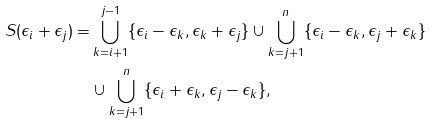Convert formula to latex. <formula><loc_0><loc_0><loc_500><loc_500>S ( \epsilon _ { i } + \epsilon _ { j } ) = & \bigcup _ { k = i + 1 } ^ { j - 1 } \{ \epsilon _ { i } - \epsilon _ { k } , \epsilon _ { k } + \epsilon _ { j } \} \cup \bigcup _ { k = j + 1 } ^ { n } \{ \epsilon _ { i } - \epsilon _ { k } , \epsilon _ { j } + \epsilon _ { k } \} \\ & \cup \bigcup _ { k = j + 1 } ^ { n } \{ \epsilon _ { i } + \epsilon _ { k } , \epsilon _ { j } - \epsilon _ { k } \} ,</formula> 